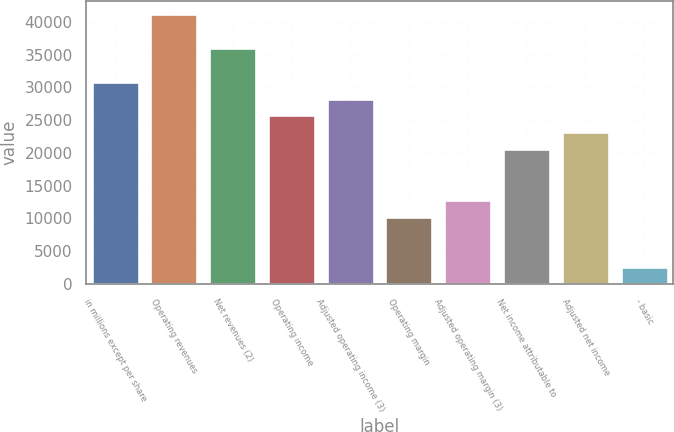<chart> <loc_0><loc_0><loc_500><loc_500><bar_chart><fcel>in millions except per share<fcel>Operating revenues<fcel>Net revenues (2)<fcel>Operating income<fcel>Adjusted operating income (3)<fcel>Operating margin<fcel>Adjusted operating margin (3)<fcel>Net income attributable to<fcel>Adjusted net income<fcel>- basic<nl><fcel>30881<fcel>41174.2<fcel>36027.6<fcel>25734.3<fcel>28307.6<fcel>10294.4<fcel>12867.7<fcel>20587.7<fcel>23161<fcel>2574.43<nl></chart> 